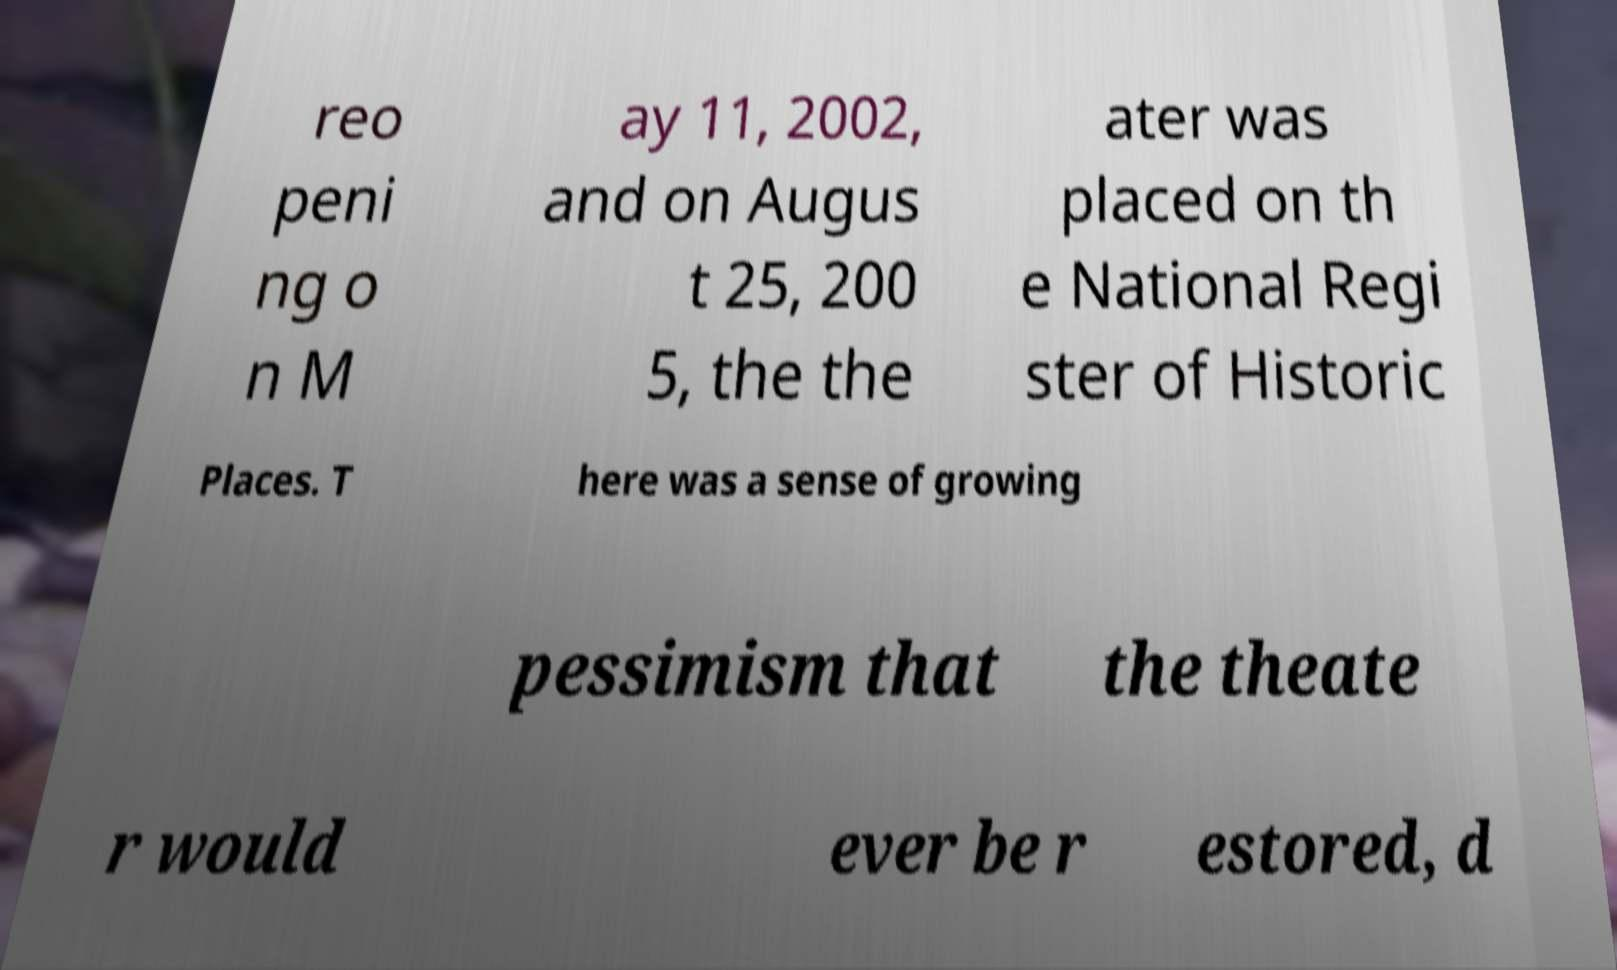Can you read and provide the text displayed in the image?This photo seems to have some interesting text. Can you extract and type it out for me? reo peni ng o n M ay 11, 2002, and on Augus t 25, 200 5, the the ater was placed on th e National Regi ster of Historic Places. T here was a sense of growing pessimism that the theate r would ever be r estored, d 